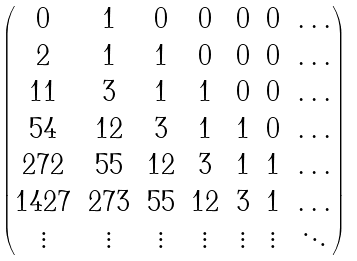<formula> <loc_0><loc_0><loc_500><loc_500>\begin{pmatrix} 0 & 1 & 0 & 0 & 0 & 0 & \dots \\ 2 & 1 & 1 & 0 & 0 & 0 & \dots \\ 1 1 & 3 & 1 & 1 & 0 & 0 & \dots \\ 5 4 & 1 2 & 3 & 1 & 1 & 0 & \dots \\ 2 7 2 & 5 5 & 1 2 & 3 & 1 & 1 & \dots \\ 1 4 2 7 & 2 7 3 & 5 5 & 1 2 & 3 & 1 & \dots \\ \vdots & \vdots & \vdots & \vdots & \vdots & \vdots & \ddots \end{pmatrix}</formula> 